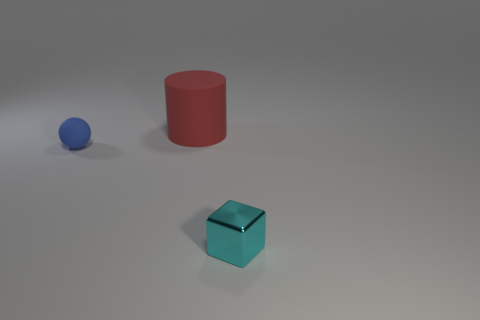Are there any other things that have the same size as the rubber cylinder?
Your answer should be compact. No. There is a tiny thing that is behind the cyan cube that is to the right of the rubber cylinder; are there any rubber things that are to the right of it?
Your response must be concise. Yes. The block has what color?
Your response must be concise. Cyan. There is a small blue thing; are there any small spheres in front of it?
Provide a succinct answer. No. There is a tiny blue thing; is its shape the same as the small thing that is to the right of the large rubber thing?
Offer a very short reply. No. How many other things are there of the same material as the small cyan block?
Provide a short and direct response. 0. What color is the thing that is in front of the small thing behind the tiny metal thing on the right side of the large red thing?
Offer a terse response. Cyan. There is a matte object that is on the right side of the small thing that is to the left of the red rubber cylinder; what shape is it?
Offer a very short reply. Cylinder. Are there more blue rubber balls that are in front of the large red matte thing than red matte objects?
Give a very brief answer. No. Is the shape of the tiny object that is in front of the tiny blue matte sphere the same as  the red object?
Give a very brief answer. No. 